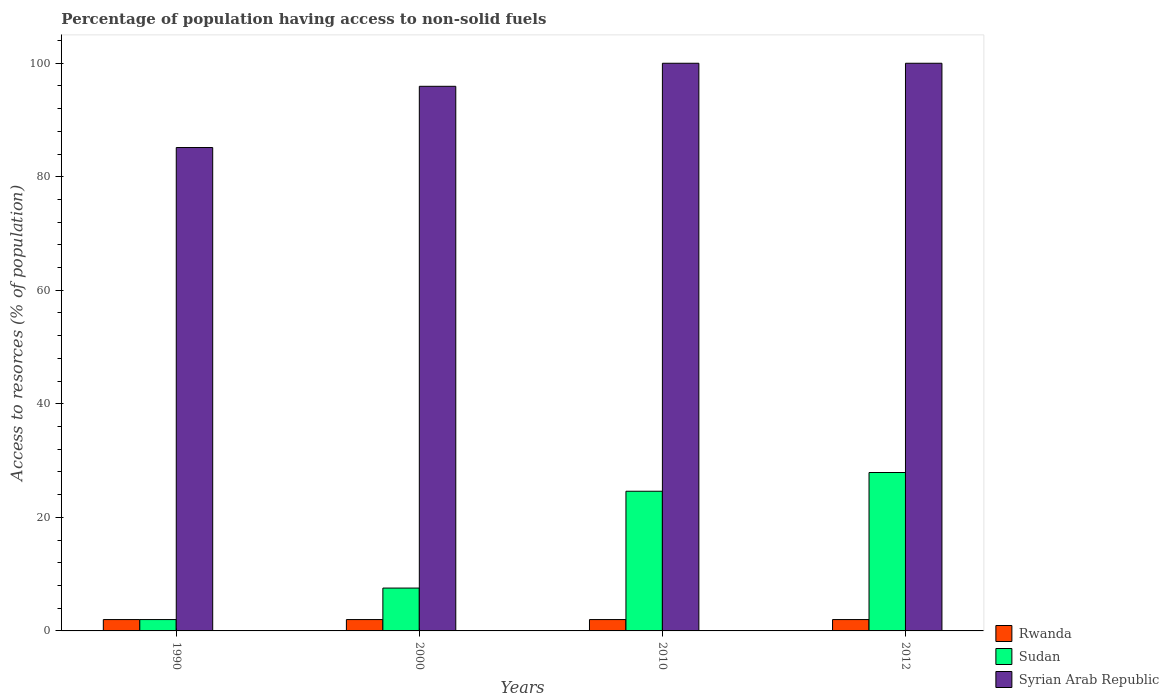How many groups of bars are there?
Make the answer very short. 4. What is the percentage of population having access to non-solid fuels in Rwanda in 1990?
Give a very brief answer. 2. Across all years, what is the maximum percentage of population having access to non-solid fuels in Syrian Arab Republic?
Offer a terse response. 99.99. Across all years, what is the minimum percentage of population having access to non-solid fuels in Sudan?
Provide a succinct answer. 2. In which year was the percentage of population having access to non-solid fuels in Rwanda minimum?
Your response must be concise. 1990. What is the total percentage of population having access to non-solid fuels in Rwanda in the graph?
Offer a terse response. 8. What is the average percentage of population having access to non-solid fuels in Sudan per year?
Provide a succinct answer. 15.51. In the year 2000, what is the difference between the percentage of population having access to non-solid fuels in Syrian Arab Republic and percentage of population having access to non-solid fuels in Rwanda?
Provide a short and direct response. 93.93. What is the ratio of the percentage of population having access to non-solid fuels in Syrian Arab Republic in 1990 to that in 2000?
Your response must be concise. 0.89. Is the difference between the percentage of population having access to non-solid fuels in Syrian Arab Republic in 1990 and 2010 greater than the difference between the percentage of population having access to non-solid fuels in Rwanda in 1990 and 2010?
Your response must be concise. No. What is the difference between the highest and the lowest percentage of population having access to non-solid fuels in Sudan?
Offer a terse response. 25.9. In how many years, is the percentage of population having access to non-solid fuels in Rwanda greater than the average percentage of population having access to non-solid fuels in Rwanda taken over all years?
Your response must be concise. 0. Is the sum of the percentage of population having access to non-solid fuels in Syrian Arab Republic in 2010 and 2012 greater than the maximum percentage of population having access to non-solid fuels in Sudan across all years?
Offer a terse response. Yes. What does the 3rd bar from the left in 2010 represents?
Make the answer very short. Syrian Arab Republic. What does the 2nd bar from the right in 2010 represents?
Ensure brevity in your answer.  Sudan. How many bars are there?
Ensure brevity in your answer.  12. How many years are there in the graph?
Give a very brief answer. 4. What is the difference between two consecutive major ticks on the Y-axis?
Your response must be concise. 20. Does the graph contain grids?
Give a very brief answer. No. How many legend labels are there?
Provide a succinct answer. 3. What is the title of the graph?
Offer a very short reply. Percentage of population having access to non-solid fuels. Does "Belarus" appear as one of the legend labels in the graph?
Provide a succinct answer. No. What is the label or title of the Y-axis?
Provide a succinct answer. Access to resorces (% of population). What is the Access to resorces (% of population) of Rwanda in 1990?
Your answer should be compact. 2. What is the Access to resorces (% of population) in Sudan in 1990?
Make the answer very short. 2. What is the Access to resorces (% of population) in Syrian Arab Republic in 1990?
Give a very brief answer. 85.15. What is the Access to resorces (% of population) of Rwanda in 2000?
Your response must be concise. 2. What is the Access to resorces (% of population) in Sudan in 2000?
Keep it short and to the point. 7.55. What is the Access to resorces (% of population) in Syrian Arab Republic in 2000?
Give a very brief answer. 95.93. What is the Access to resorces (% of population) in Rwanda in 2010?
Offer a terse response. 2. What is the Access to resorces (% of population) of Sudan in 2010?
Offer a very short reply. 24.6. What is the Access to resorces (% of population) in Syrian Arab Republic in 2010?
Keep it short and to the point. 99.99. What is the Access to resorces (% of population) in Rwanda in 2012?
Your response must be concise. 2. What is the Access to resorces (% of population) of Sudan in 2012?
Provide a succinct answer. 27.9. What is the Access to resorces (% of population) of Syrian Arab Republic in 2012?
Offer a very short reply. 99.99. Across all years, what is the maximum Access to resorces (% of population) in Rwanda?
Ensure brevity in your answer.  2. Across all years, what is the maximum Access to resorces (% of population) of Sudan?
Your response must be concise. 27.9. Across all years, what is the maximum Access to resorces (% of population) of Syrian Arab Republic?
Give a very brief answer. 99.99. Across all years, what is the minimum Access to resorces (% of population) of Rwanda?
Provide a succinct answer. 2. Across all years, what is the minimum Access to resorces (% of population) of Sudan?
Make the answer very short. 2. Across all years, what is the minimum Access to resorces (% of population) in Syrian Arab Republic?
Give a very brief answer. 85.15. What is the total Access to resorces (% of population) in Rwanda in the graph?
Provide a short and direct response. 8. What is the total Access to resorces (% of population) in Sudan in the graph?
Give a very brief answer. 62.06. What is the total Access to resorces (% of population) in Syrian Arab Republic in the graph?
Ensure brevity in your answer.  381.06. What is the difference between the Access to resorces (% of population) in Sudan in 1990 and that in 2000?
Provide a succinct answer. -5.55. What is the difference between the Access to resorces (% of population) of Syrian Arab Republic in 1990 and that in 2000?
Give a very brief answer. -10.78. What is the difference between the Access to resorces (% of population) in Rwanda in 1990 and that in 2010?
Your answer should be very brief. 0. What is the difference between the Access to resorces (% of population) of Sudan in 1990 and that in 2010?
Your response must be concise. -22.6. What is the difference between the Access to resorces (% of population) in Syrian Arab Republic in 1990 and that in 2010?
Offer a terse response. -14.84. What is the difference between the Access to resorces (% of population) in Sudan in 1990 and that in 2012?
Your response must be concise. -25.9. What is the difference between the Access to resorces (% of population) in Syrian Arab Republic in 1990 and that in 2012?
Make the answer very short. -14.84. What is the difference between the Access to resorces (% of population) in Rwanda in 2000 and that in 2010?
Provide a succinct answer. 0. What is the difference between the Access to resorces (% of population) in Sudan in 2000 and that in 2010?
Make the answer very short. -17.06. What is the difference between the Access to resorces (% of population) of Syrian Arab Republic in 2000 and that in 2010?
Offer a terse response. -4.06. What is the difference between the Access to resorces (% of population) in Sudan in 2000 and that in 2012?
Give a very brief answer. -20.36. What is the difference between the Access to resorces (% of population) in Syrian Arab Republic in 2000 and that in 2012?
Offer a very short reply. -4.06. What is the difference between the Access to resorces (% of population) in Sudan in 2010 and that in 2012?
Keep it short and to the point. -3.3. What is the difference between the Access to resorces (% of population) of Rwanda in 1990 and the Access to resorces (% of population) of Sudan in 2000?
Offer a very short reply. -5.55. What is the difference between the Access to resorces (% of population) in Rwanda in 1990 and the Access to resorces (% of population) in Syrian Arab Republic in 2000?
Ensure brevity in your answer.  -93.93. What is the difference between the Access to resorces (% of population) in Sudan in 1990 and the Access to resorces (% of population) in Syrian Arab Republic in 2000?
Give a very brief answer. -93.93. What is the difference between the Access to resorces (% of population) in Rwanda in 1990 and the Access to resorces (% of population) in Sudan in 2010?
Your response must be concise. -22.6. What is the difference between the Access to resorces (% of population) of Rwanda in 1990 and the Access to resorces (% of population) of Syrian Arab Republic in 2010?
Keep it short and to the point. -97.99. What is the difference between the Access to resorces (% of population) of Sudan in 1990 and the Access to resorces (% of population) of Syrian Arab Republic in 2010?
Provide a succinct answer. -97.99. What is the difference between the Access to resorces (% of population) in Rwanda in 1990 and the Access to resorces (% of population) in Sudan in 2012?
Give a very brief answer. -25.9. What is the difference between the Access to resorces (% of population) of Rwanda in 1990 and the Access to resorces (% of population) of Syrian Arab Republic in 2012?
Keep it short and to the point. -97.99. What is the difference between the Access to resorces (% of population) in Sudan in 1990 and the Access to resorces (% of population) in Syrian Arab Republic in 2012?
Offer a terse response. -97.99. What is the difference between the Access to resorces (% of population) of Rwanda in 2000 and the Access to resorces (% of population) of Sudan in 2010?
Provide a succinct answer. -22.6. What is the difference between the Access to resorces (% of population) in Rwanda in 2000 and the Access to resorces (% of population) in Syrian Arab Republic in 2010?
Provide a short and direct response. -97.99. What is the difference between the Access to resorces (% of population) of Sudan in 2000 and the Access to resorces (% of population) of Syrian Arab Republic in 2010?
Keep it short and to the point. -92.44. What is the difference between the Access to resorces (% of population) in Rwanda in 2000 and the Access to resorces (% of population) in Sudan in 2012?
Make the answer very short. -25.9. What is the difference between the Access to resorces (% of population) of Rwanda in 2000 and the Access to resorces (% of population) of Syrian Arab Republic in 2012?
Your answer should be very brief. -97.99. What is the difference between the Access to resorces (% of population) of Sudan in 2000 and the Access to resorces (% of population) of Syrian Arab Republic in 2012?
Provide a succinct answer. -92.44. What is the difference between the Access to resorces (% of population) of Rwanda in 2010 and the Access to resorces (% of population) of Sudan in 2012?
Give a very brief answer. -25.9. What is the difference between the Access to resorces (% of population) in Rwanda in 2010 and the Access to resorces (% of population) in Syrian Arab Republic in 2012?
Your response must be concise. -97.99. What is the difference between the Access to resorces (% of population) in Sudan in 2010 and the Access to resorces (% of population) in Syrian Arab Republic in 2012?
Your answer should be compact. -75.39. What is the average Access to resorces (% of population) in Rwanda per year?
Your answer should be very brief. 2. What is the average Access to resorces (% of population) of Sudan per year?
Provide a succinct answer. 15.51. What is the average Access to resorces (% of population) of Syrian Arab Republic per year?
Your answer should be compact. 95.26. In the year 1990, what is the difference between the Access to resorces (% of population) in Rwanda and Access to resorces (% of population) in Syrian Arab Republic?
Give a very brief answer. -83.15. In the year 1990, what is the difference between the Access to resorces (% of population) of Sudan and Access to resorces (% of population) of Syrian Arab Republic?
Your response must be concise. -83.15. In the year 2000, what is the difference between the Access to resorces (% of population) in Rwanda and Access to resorces (% of population) in Sudan?
Offer a terse response. -5.55. In the year 2000, what is the difference between the Access to resorces (% of population) in Rwanda and Access to resorces (% of population) in Syrian Arab Republic?
Your response must be concise. -93.93. In the year 2000, what is the difference between the Access to resorces (% of population) in Sudan and Access to resorces (% of population) in Syrian Arab Republic?
Provide a short and direct response. -88.38. In the year 2010, what is the difference between the Access to resorces (% of population) of Rwanda and Access to resorces (% of population) of Sudan?
Offer a terse response. -22.6. In the year 2010, what is the difference between the Access to resorces (% of population) in Rwanda and Access to resorces (% of population) in Syrian Arab Republic?
Keep it short and to the point. -97.99. In the year 2010, what is the difference between the Access to resorces (% of population) of Sudan and Access to resorces (% of population) of Syrian Arab Republic?
Give a very brief answer. -75.39. In the year 2012, what is the difference between the Access to resorces (% of population) in Rwanda and Access to resorces (% of population) in Sudan?
Provide a short and direct response. -25.9. In the year 2012, what is the difference between the Access to resorces (% of population) in Rwanda and Access to resorces (% of population) in Syrian Arab Republic?
Your answer should be compact. -97.99. In the year 2012, what is the difference between the Access to resorces (% of population) in Sudan and Access to resorces (% of population) in Syrian Arab Republic?
Provide a short and direct response. -72.09. What is the ratio of the Access to resorces (% of population) of Rwanda in 1990 to that in 2000?
Your answer should be compact. 1. What is the ratio of the Access to resorces (% of population) of Sudan in 1990 to that in 2000?
Your response must be concise. 0.27. What is the ratio of the Access to resorces (% of population) in Syrian Arab Republic in 1990 to that in 2000?
Keep it short and to the point. 0.89. What is the ratio of the Access to resorces (% of population) of Rwanda in 1990 to that in 2010?
Your response must be concise. 1. What is the ratio of the Access to resorces (% of population) in Sudan in 1990 to that in 2010?
Offer a very short reply. 0.08. What is the ratio of the Access to resorces (% of population) of Syrian Arab Republic in 1990 to that in 2010?
Your response must be concise. 0.85. What is the ratio of the Access to resorces (% of population) of Sudan in 1990 to that in 2012?
Give a very brief answer. 0.07. What is the ratio of the Access to resorces (% of population) of Syrian Arab Republic in 1990 to that in 2012?
Make the answer very short. 0.85. What is the ratio of the Access to resorces (% of population) in Sudan in 2000 to that in 2010?
Ensure brevity in your answer.  0.31. What is the ratio of the Access to resorces (% of population) in Syrian Arab Republic in 2000 to that in 2010?
Keep it short and to the point. 0.96. What is the ratio of the Access to resorces (% of population) in Rwanda in 2000 to that in 2012?
Your response must be concise. 1. What is the ratio of the Access to resorces (% of population) in Sudan in 2000 to that in 2012?
Your response must be concise. 0.27. What is the ratio of the Access to resorces (% of population) of Syrian Arab Republic in 2000 to that in 2012?
Ensure brevity in your answer.  0.96. What is the ratio of the Access to resorces (% of population) in Sudan in 2010 to that in 2012?
Ensure brevity in your answer.  0.88. What is the difference between the highest and the second highest Access to resorces (% of population) in Rwanda?
Your answer should be compact. 0. What is the difference between the highest and the second highest Access to resorces (% of population) of Sudan?
Your response must be concise. 3.3. What is the difference between the highest and the lowest Access to resorces (% of population) of Rwanda?
Provide a short and direct response. 0. What is the difference between the highest and the lowest Access to resorces (% of population) of Sudan?
Ensure brevity in your answer.  25.9. What is the difference between the highest and the lowest Access to resorces (% of population) of Syrian Arab Republic?
Keep it short and to the point. 14.84. 